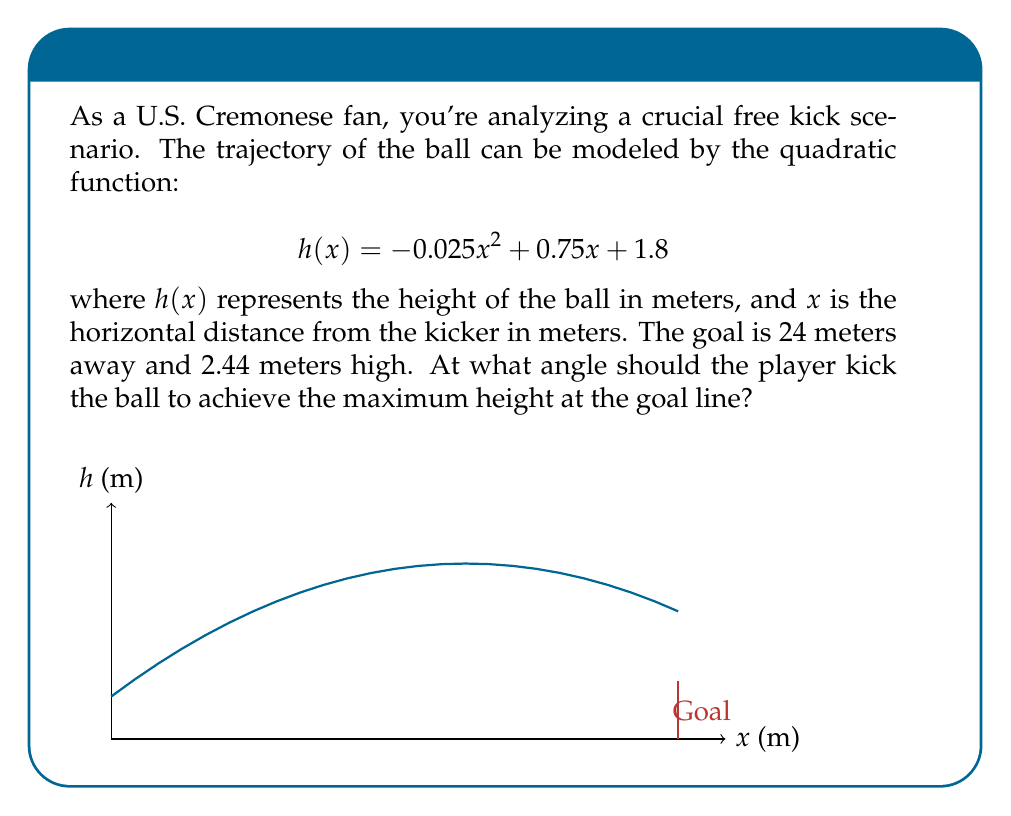What is the answer to this math problem? To solve this problem, we'll follow these steps:

1) The maximum height occurs at the vertex of the parabola. We need to find the x-coordinate of the vertex.

2) For a quadratic function in the form $f(x) = ax^2 + bx + c$, the x-coordinate of the vertex is given by $x = -\frac{b}{2a}$.

3) In our function $h(x) = -0.025x^2 + 0.75x + 1.8$, we have:
   $a = -0.025$
   $b = 0.75$
   $c = 1.8$

4) Plugging into the vertex formula:
   $$x = -\frac{0.75}{2(-0.025)} = \frac{0.75}{0.05} = 15$$

5) The vertex occurs at $x = 15$ meters. This is where the ball reaches its maximum height.

6) To find the angle, we need to calculate the height at this point:
   $h(15) = -0.025(15)^2 + 0.75(15) + 1.8 = 7.425$ meters

7) Now we have a right triangle with:
   - Base = 15 meters
   - Height = 7.425 - 1.8 = 5.625 meters (subtracting initial height)

8) The angle can be calculated using arctangent:
   $$\theta = \arctan(\frac{5.625}{15}) \approx 20.556°$$

Therefore, the optimal angle for the free kick is approximately 20.556°.
Answer: $20.556°$ 